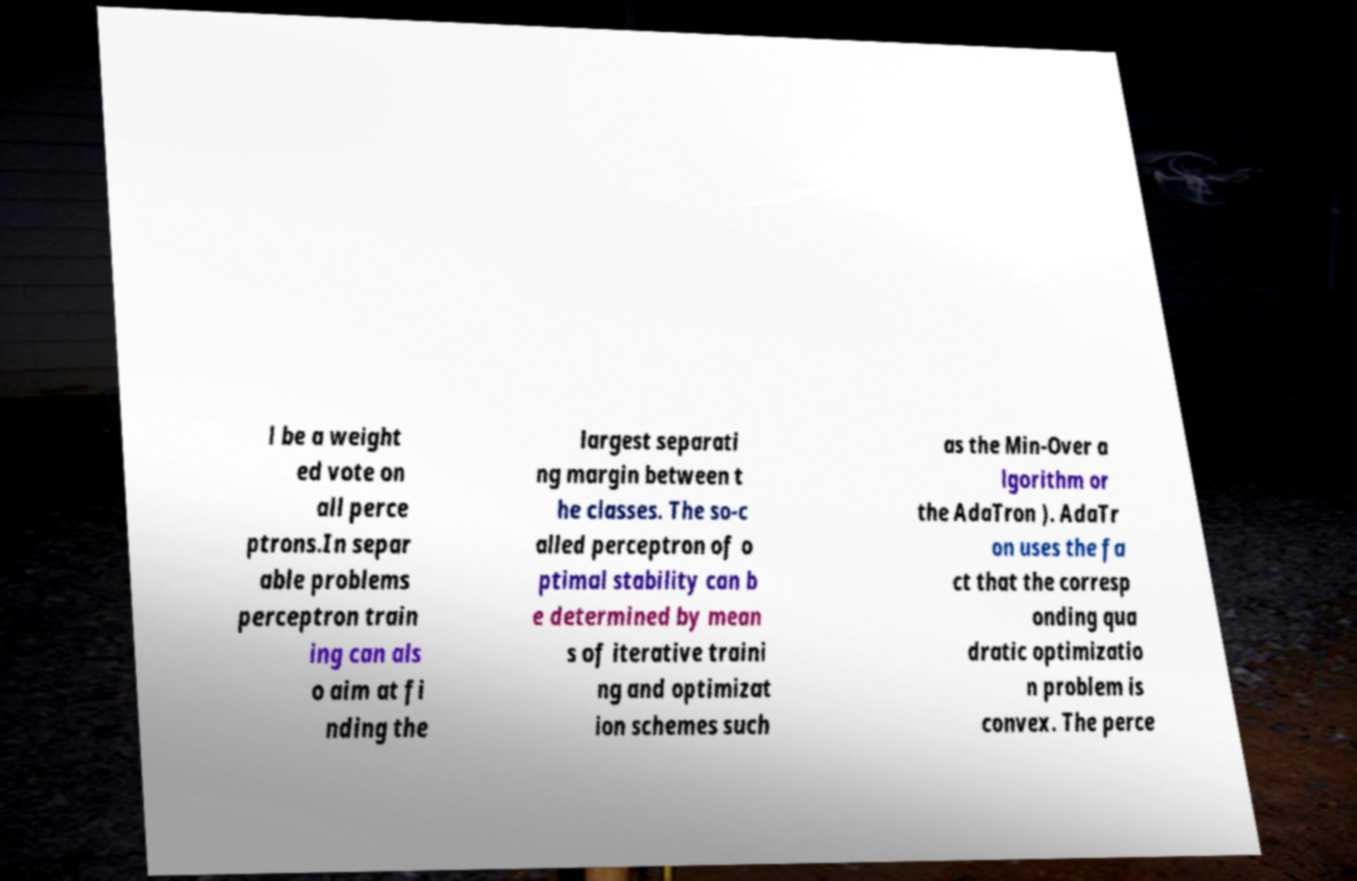Could you assist in decoding the text presented in this image and type it out clearly? l be a weight ed vote on all perce ptrons.In separ able problems perceptron train ing can als o aim at fi nding the largest separati ng margin between t he classes. The so-c alled perceptron of o ptimal stability can b e determined by mean s of iterative traini ng and optimizat ion schemes such as the Min-Over a lgorithm or the AdaTron ). AdaTr on uses the fa ct that the corresp onding qua dratic optimizatio n problem is convex. The perce 